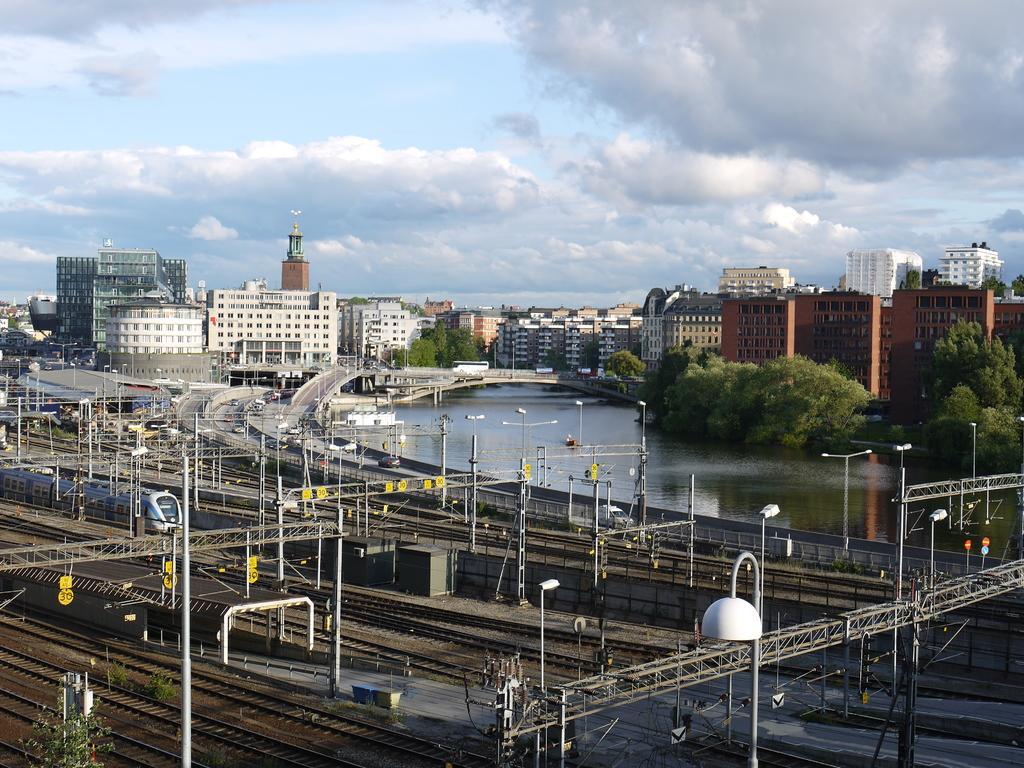Please provide a concise description of this image. In this picture we can see few poles, lights and trains on the tracks, in the background we can find few buildings, water, trees, vehicles and clouds. 